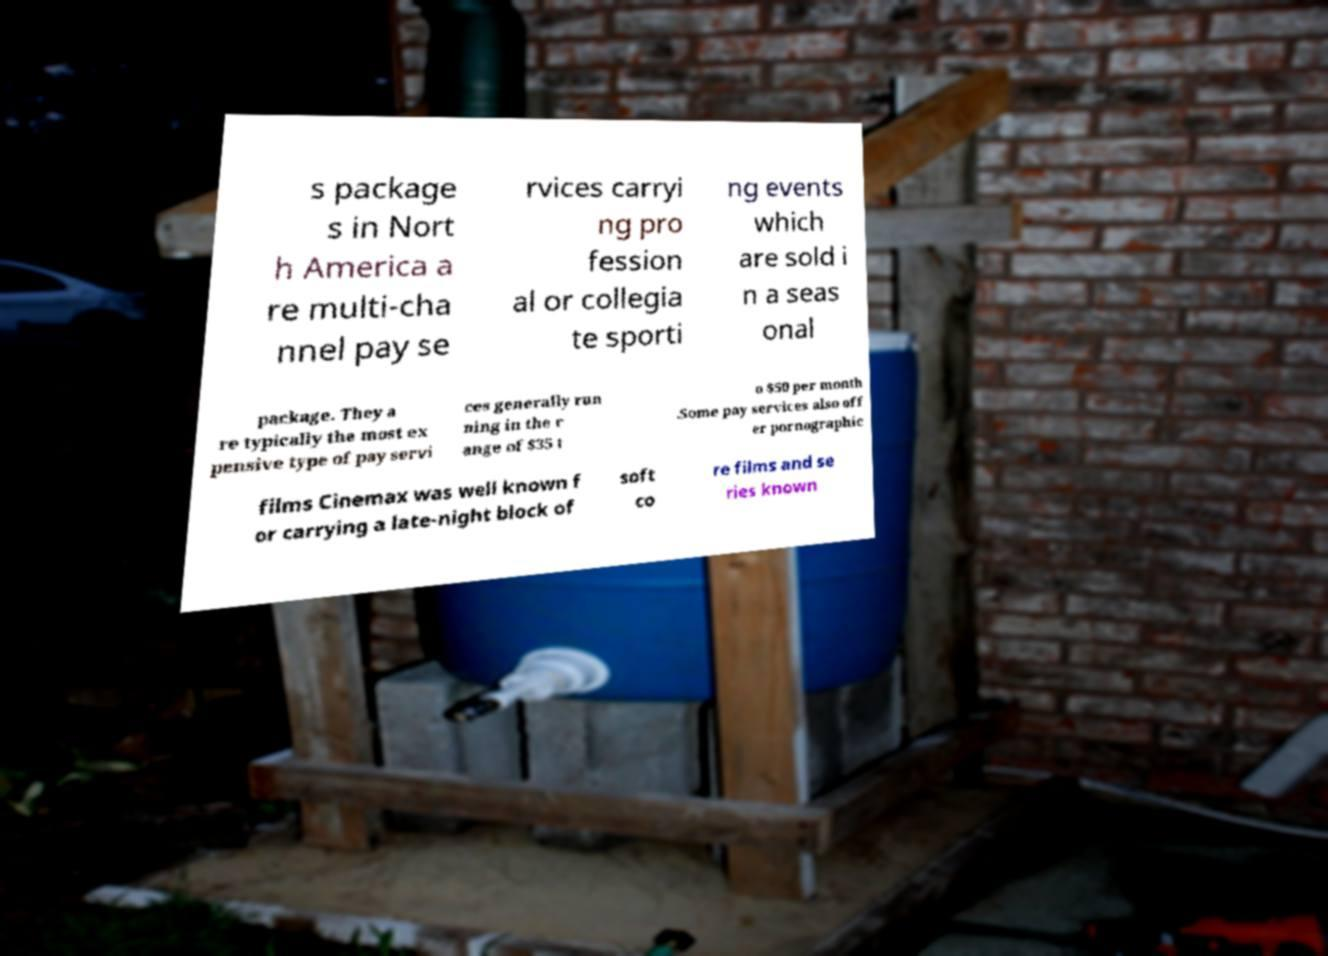I need the written content from this picture converted into text. Can you do that? s package s in Nort h America a re multi-cha nnel pay se rvices carryi ng pro fession al or collegia te sporti ng events which are sold i n a seas onal package. They a re typically the most ex pensive type of pay servi ces generally run ning in the r ange of $35 t o $50 per month .Some pay services also off er pornographic films Cinemax was well known f or carrying a late-night block of soft co re films and se ries known 